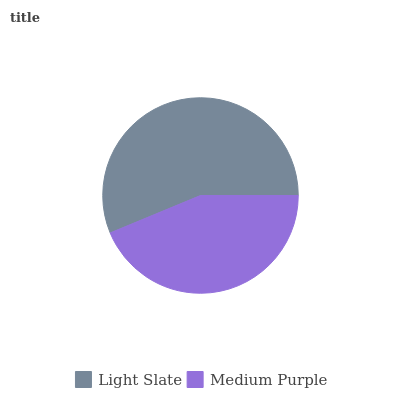Is Medium Purple the minimum?
Answer yes or no. Yes. Is Light Slate the maximum?
Answer yes or no. Yes. Is Medium Purple the maximum?
Answer yes or no. No. Is Light Slate greater than Medium Purple?
Answer yes or no. Yes. Is Medium Purple less than Light Slate?
Answer yes or no. Yes. Is Medium Purple greater than Light Slate?
Answer yes or no. No. Is Light Slate less than Medium Purple?
Answer yes or no. No. Is Light Slate the high median?
Answer yes or no. Yes. Is Medium Purple the low median?
Answer yes or no. Yes. Is Medium Purple the high median?
Answer yes or no. No. Is Light Slate the low median?
Answer yes or no. No. 